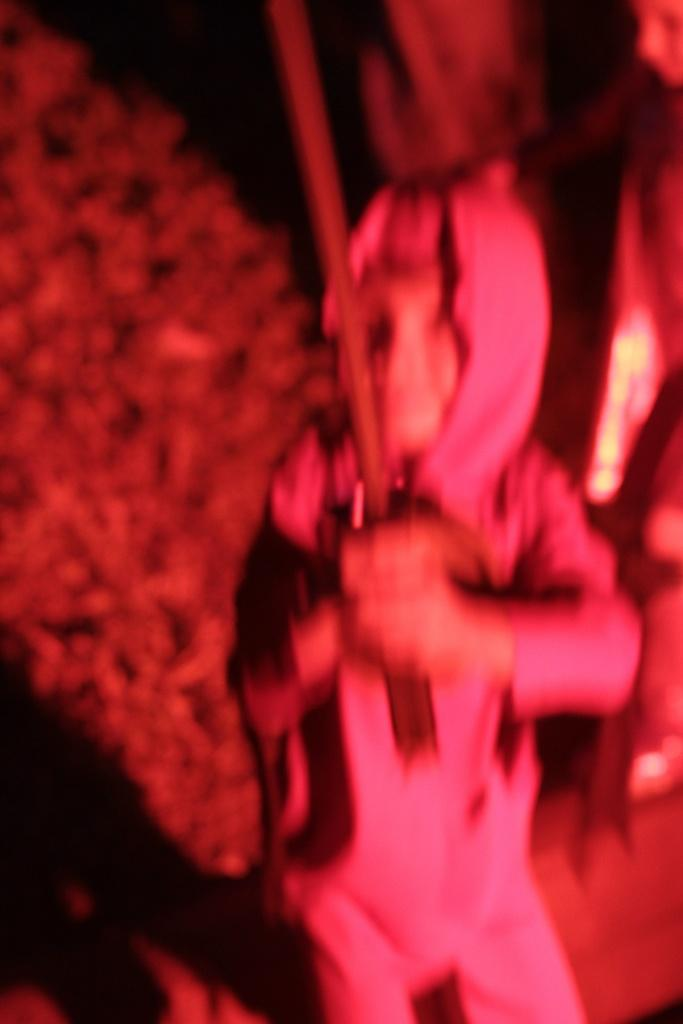What is the main subject of the image? There is a person in the image. What is the person holding in the image? The person is holding a stick. Can you describe the background of the image? The background of the image is blurred. What type of vest is the person wearing in the image? There is no vest visible in the image; the person is holding a stick. What is the texture of the volleyball in the image? There is no volleyball present in the image. 